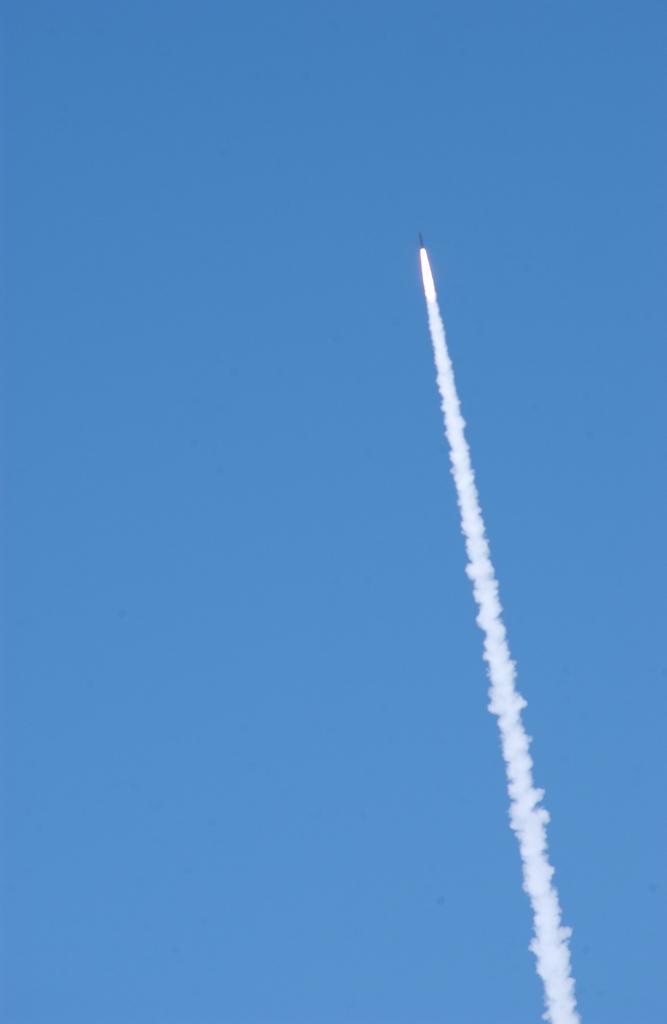Please provide a concise description of this image. In this image there is a rocket flying and there is fog, in the background there is sky. 